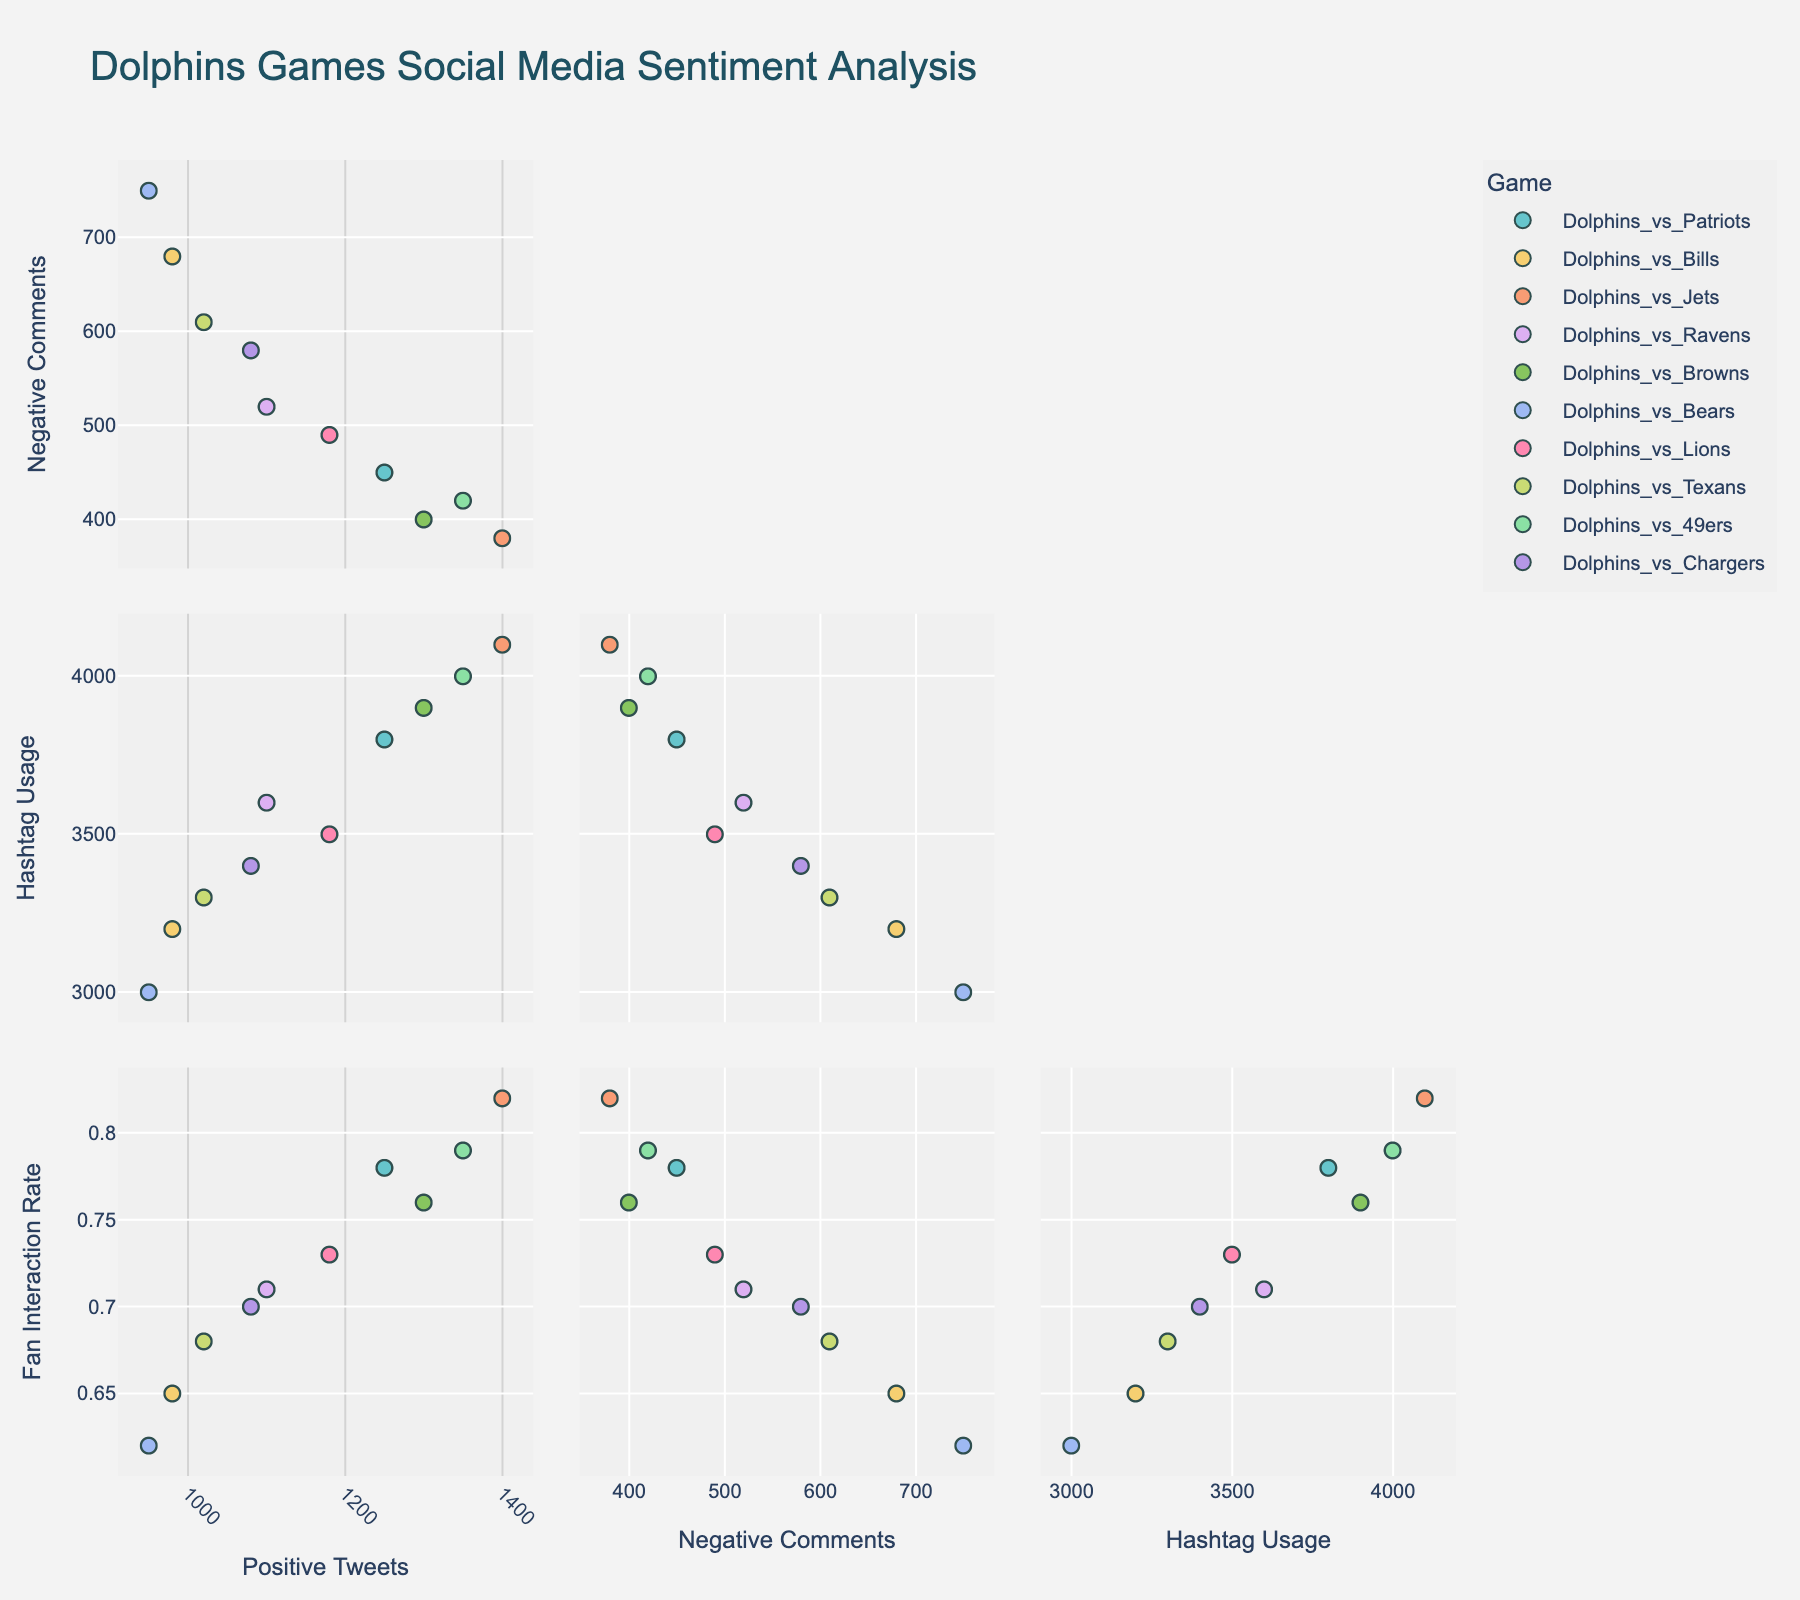Which game had the highest number of positive tweets? Look at the data points representing the number of positive tweets on the 'Positive_Tweets' axis. The game with the highest value is the Dolphins vs. Jets.
Answer: Dolphins vs. Jets Is there a clear trend between positive tweets and fan interaction rate? Observe the scatterplot matrix focusing on the plot between 'Positive_Tweets' and 'Fan_Interaction_Rate'. There is a positive correlation where higher numbers of positive tweets correspond to higher fan interaction rates.
Answer: Yes, a positive trend Which game showed the highest negative comments but also had a high hashtag usage? Examining the scatterplots for 'Negative_Comments' and 'Hashtag_Usage', identify the game with a high value on both axes. The Dolphins vs. Bears had the highest negative comments and relatively high hashtag usage.
Answer: Dolphins vs. Bears Do games with higher positive tweets also generally have higher hashtag usage? Check the plot comparing 'Positive_Tweets' and 'Hashtag_Usage'. Most games with high positive tweets also show high hashtag usage, indicating a positive correlation.
Answer: Yes, generally Which game had the highest fan interaction rate? Identify the highest value on the 'Fan_Interaction_Rate' axis across all plots. The game with the highest fan interaction rate is Dolphins vs. Jets.
Answer: Dolphins vs. Jets How do negative comments compare to fan interaction rates across all games? Look at the scatterplot comparing 'Negative_Comments' and 'Fan_Interaction_Rate'. There is no clear trend, as the points are spread out without a distinct pattern.
Answer: No clear trend Do games with higher negative comments tend to have lower fan interaction rates? Focus on the relationship between 'Negative_Comments' and 'Fan_Interaction_Rate'. The correlation appears weak, suggesting no strong trend between negative comments and fan interaction rate.
Answer: No strong trend Which game had both relatively low positive tweets and low fan interaction rates? Locate the lower values on both 'Positive_Tweets' and 'Fan_Interaction_Rate' axes. The Dolphins vs. Bears game fits this criteria.
Answer: Dolphins vs. Bears Are there any games that show high positive tweets but low hashtag usage? Check the plots comparing 'Positive_Tweets' and 'Hashtag_Usage'. Typically, higher positive tweets correspond with higher hashtag usage, and no game stands out as an exception.
Answer: No exceptions Which game had the most balanced sentiment with similar numbers of positive tweets and negative comments? Look for data points closest to the diagonal line if 'Positive_Tweets' were plotted against 'Negative_Comments'. Dolphins vs. Lions and Dolphins vs. Texans are relatively balanced.
Answer: Dolphins vs. Lions and Dolphins vs. Texans 